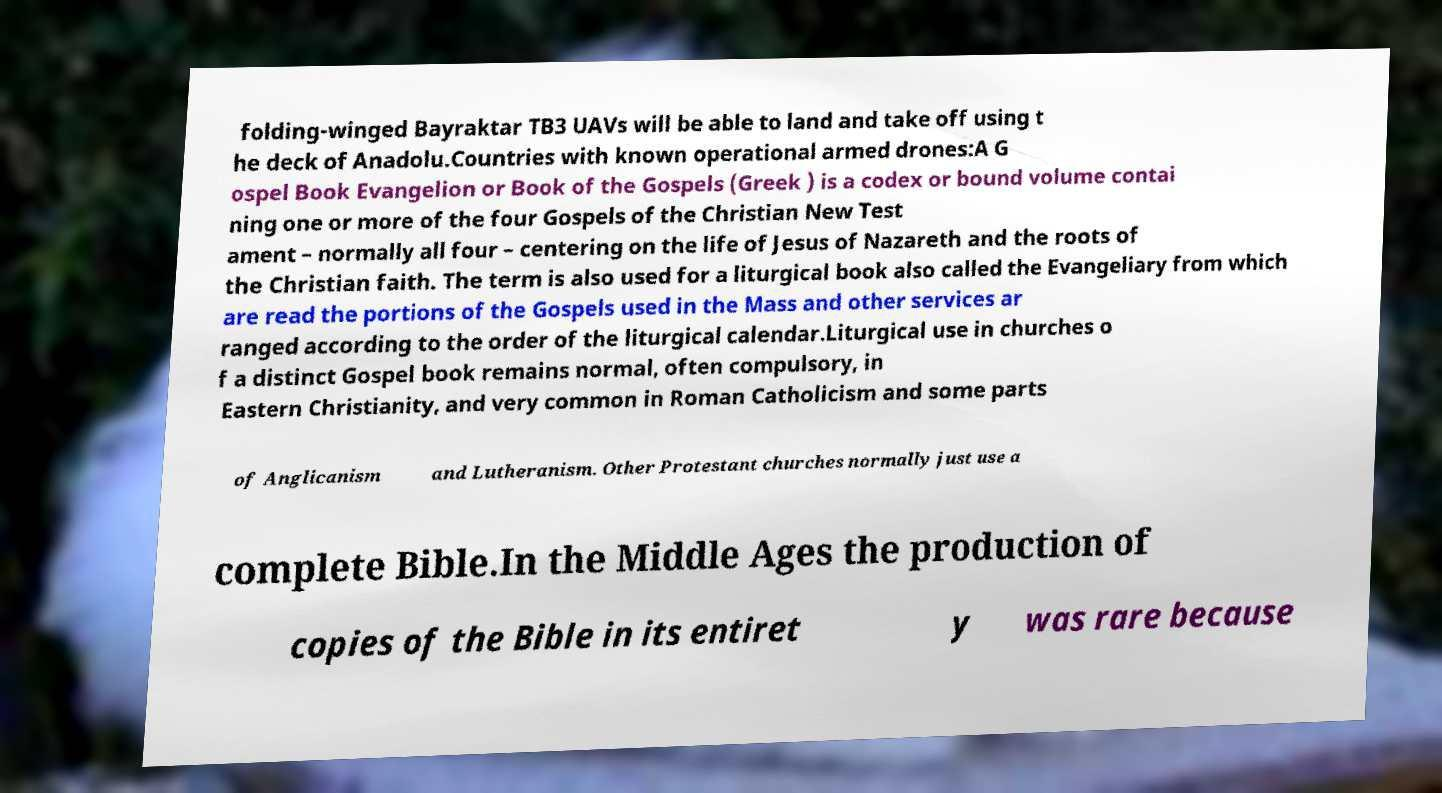Please read and relay the text visible in this image. What does it say? folding-winged Bayraktar TB3 UAVs will be able to land and take off using t he deck of Anadolu.Countries with known operational armed drones:A G ospel Book Evangelion or Book of the Gospels (Greek ) is a codex or bound volume contai ning one or more of the four Gospels of the Christian New Test ament – normally all four – centering on the life of Jesus of Nazareth and the roots of the Christian faith. The term is also used for a liturgical book also called the Evangeliary from which are read the portions of the Gospels used in the Mass and other services ar ranged according to the order of the liturgical calendar.Liturgical use in churches o f a distinct Gospel book remains normal, often compulsory, in Eastern Christianity, and very common in Roman Catholicism and some parts of Anglicanism and Lutheranism. Other Protestant churches normally just use a complete Bible.In the Middle Ages the production of copies of the Bible in its entiret y was rare because 